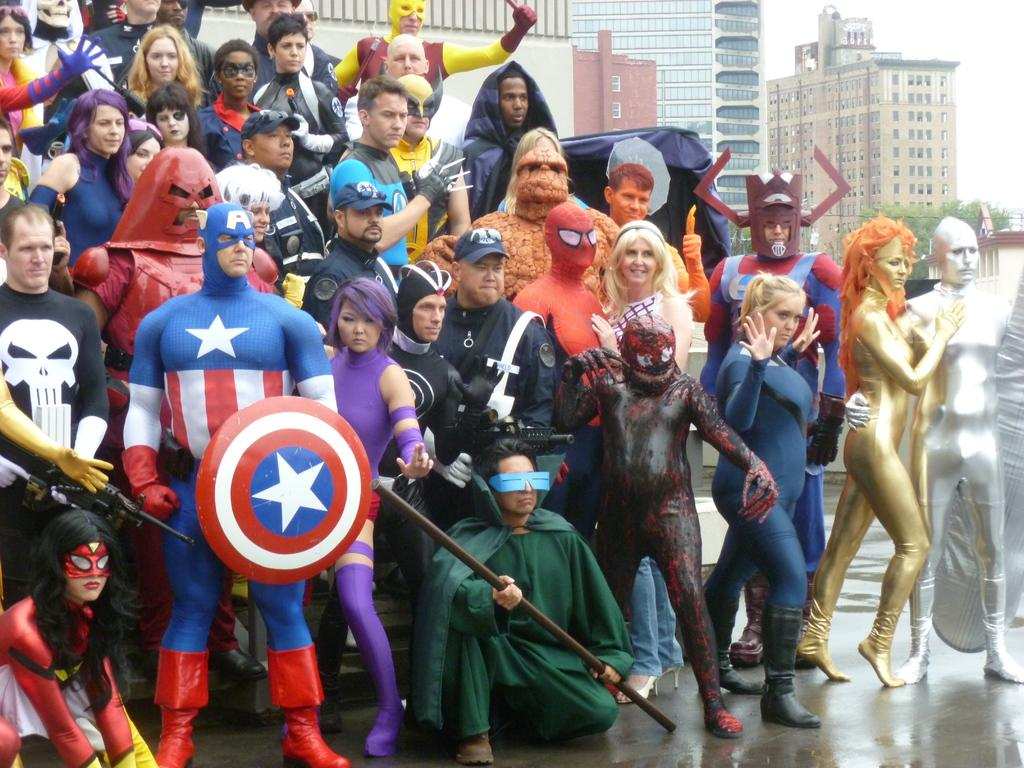What can be seen in the image involving a group of people? There is a group of people in costumes in the image. What are the people in the image holding? There are people holding objects in the image. What can be seen in the background of the image? There are buildings, trees, and the sky visible in the background of the image. What type of debt is being discussed by the people in the image? There is no indication of any debt being discussed in the image; it features a group of people in costumes holding objects. What channel is being used to broadcast the event in the image? There is no indication of any event being broadcasted in the image; it simply shows a group of people in costumes holding objects. 